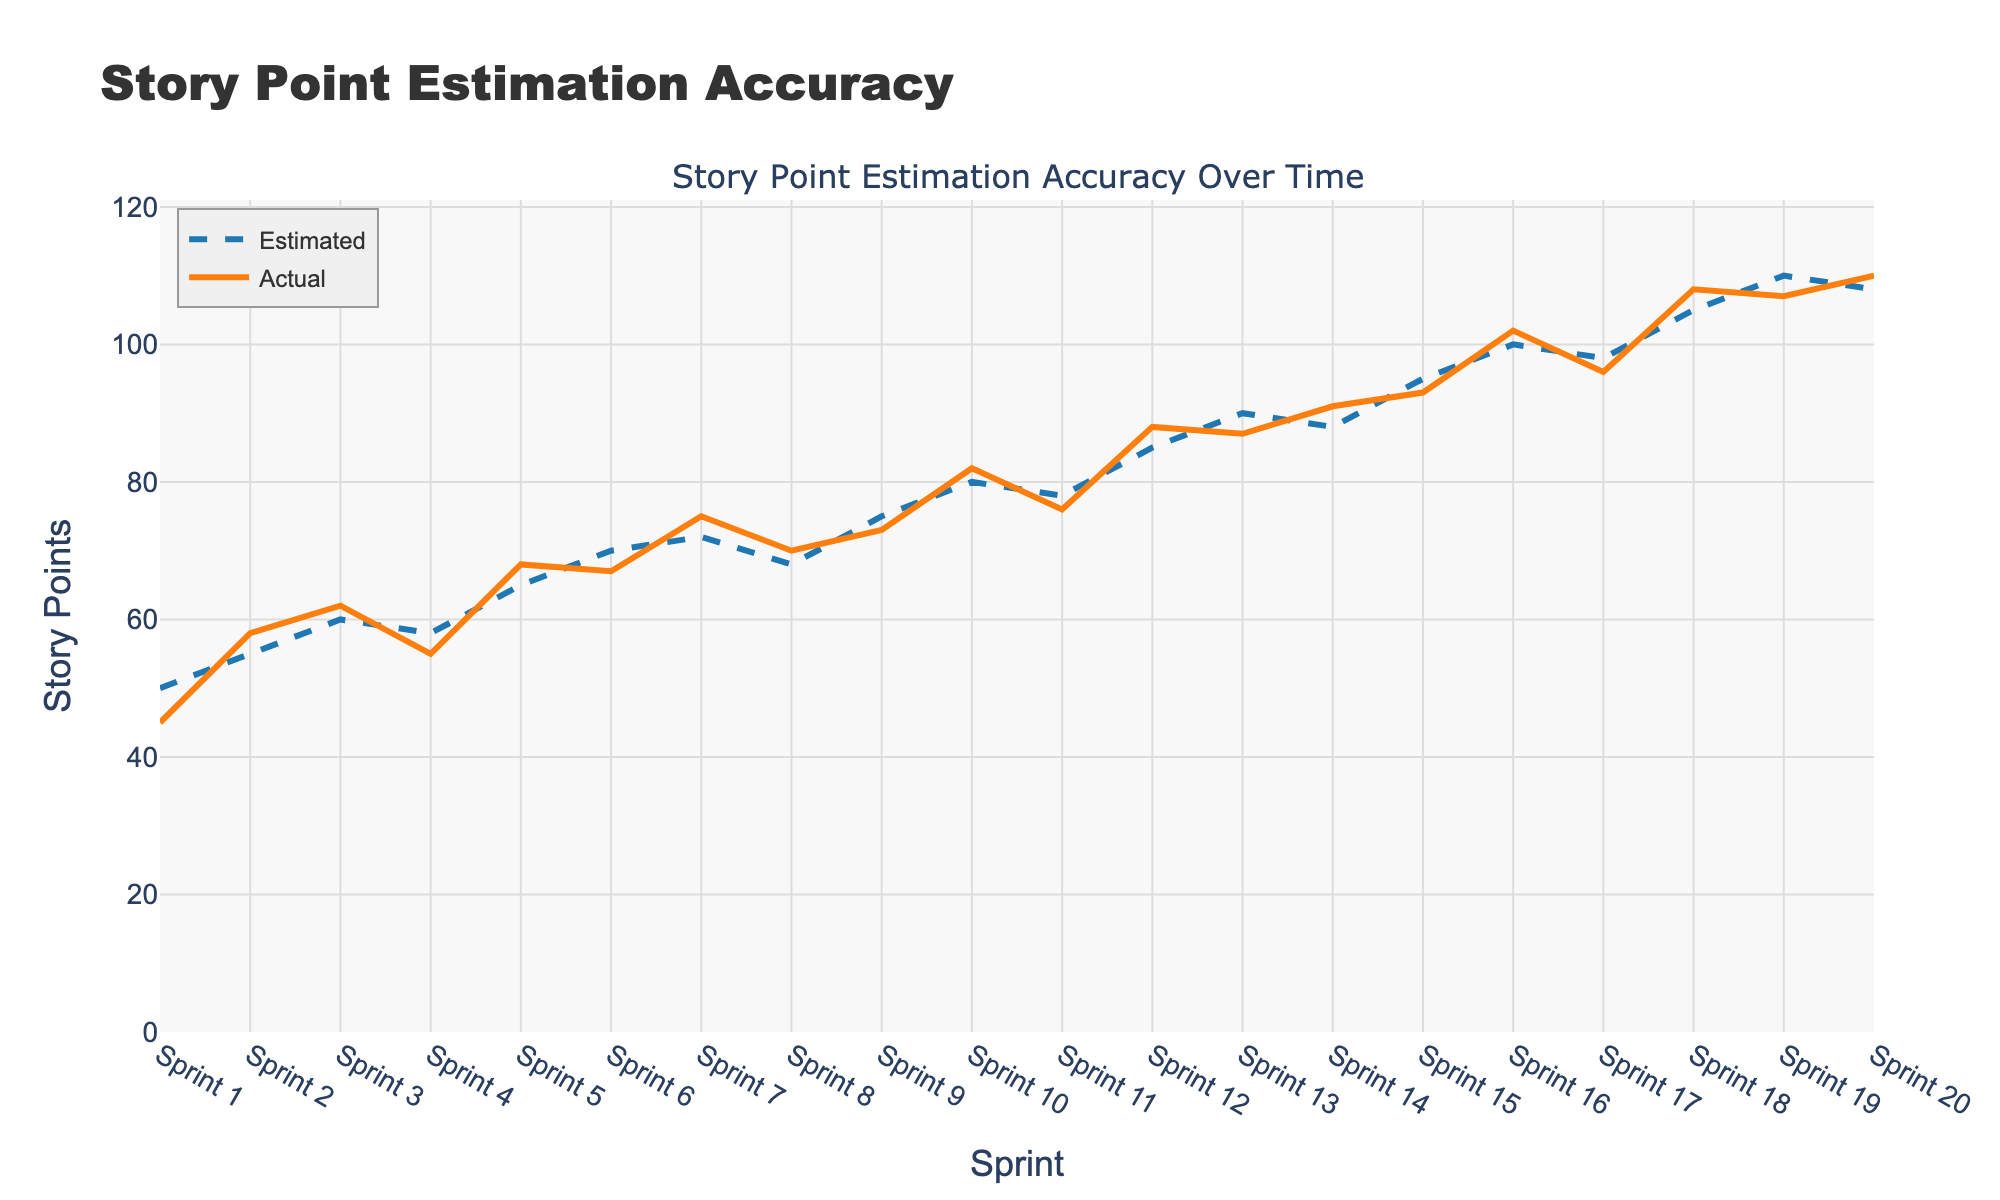Which sprints had actual story points greater than estimated story points? To find the sprints where actual story points exceed estimated story points, compare the actual and estimated values for each sprint. In Sprints 2, 3, 5, 8, 10, 12, and 14, the actual story points are greater than the estimated story points.
Answer: Sprints 2, 3, 5, 8, 10, 12, 14 What is the average of estimated and actual story points across all sprints? First, sum the estimated story points and then sum the actual story points. The total estimated points are 1,635, and actual points are 1,633. Dividing these sums by 20 (the number of sprints): Estimated average = 1,635/20 = 81.75 and Actual average = 1,633/20 = 81.65.
Answer: Estimated: 81.75, Actual: 81.65 In which sprint is the difference between estimated and actual story points the greatest? Calculate the absolute differences between estimated and actual story points for each sprint. The differences are: Sprint 1 with 5, Sprint 2 with 3, Sprint 3 with 2, and so on. Sprint 1 has the maximum difference of 5.
Answer: Sprint 1 Is there a trend between the estimated and actual story points over the sprints? To identify trends, observe the general direction of both the estimated and actual story points lines. Both lines show an increasing trend from Sprint 1 to Sprint 20, indicating that the estimation accuracy improves as total story points increase.
Answer: Yes, increasing trend Which sprint had the closest match between estimated and actual story points? Find the sprint with the minimum absolute difference between estimated and actual story points. Sprint 4 and Sprint 16 both have differences of 3, and they seem the closest matches.
Answer: Sprints 4 and 16 